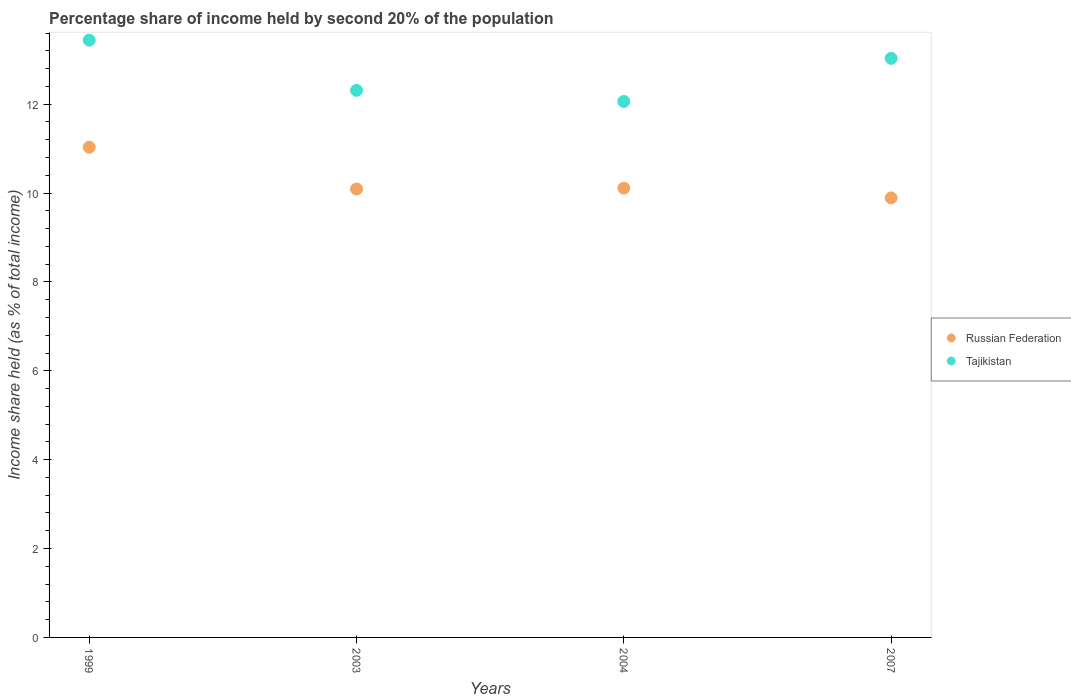How many different coloured dotlines are there?
Provide a succinct answer. 2. What is the share of income held by second 20% of the population in Russian Federation in 2004?
Provide a short and direct response. 10.11. Across all years, what is the maximum share of income held by second 20% of the population in Russian Federation?
Your answer should be very brief. 11.03. Across all years, what is the minimum share of income held by second 20% of the population in Russian Federation?
Offer a very short reply. 9.89. In which year was the share of income held by second 20% of the population in Tajikistan maximum?
Offer a very short reply. 1999. What is the total share of income held by second 20% of the population in Russian Federation in the graph?
Your answer should be compact. 41.12. What is the difference between the share of income held by second 20% of the population in Tajikistan in 1999 and that in 2007?
Ensure brevity in your answer.  0.41. What is the difference between the share of income held by second 20% of the population in Russian Federation in 2004 and the share of income held by second 20% of the population in Tajikistan in 1999?
Your answer should be very brief. -3.33. What is the average share of income held by second 20% of the population in Tajikistan per year?
Offer a very short reply. 12.71. In the year 1999, what is the difference between the share of income held by second 20% of the population in Tajikistan and share of income held by second 20% of the population in Russian Federation?
Your response must be concise. 2.41. What is the ratio of the share of income held by second 20% of the population in Tajikistan in 1999 to that in 2007?
Your answer should be compact. 1.03. Is the share of income held by second 20% of the population in Tajikistan in 1999 less than that in 2003?
Provide a succinct answer. No. What is the difference between the highest and the second highest share of income held by second 20% of the population in Tajikistan?
Your response must be concise. 0.41. What is the difference between the highest and the lowest share of income held by second 20% of the population in Tajikistan?
Your answer should be very brief. 1.38. In how many years, is the share of income held by second 20% of the population in Russian Federation greater than the average share of income held by second 20% of the population in Russian Federation taken over all years?
Your response must be concise. 1. Does the share of income held by second 20% of the population in Russian Federation monotonically increase over the years?
Make the answer very short. No. Is the share of income held by second 20% of the population in Tajikistan strictly less than the share of income held by second 20% of the population in Russian Federation over the years?
Ensure brevity in your answer.  No. Are the values on the major ticks of Y-axis written in scientific E-notation?
Your response must be concise. No. Does the graph contain any zero values?
Provide a succinct answer. No. Does the graph contain grids?
Offer a very short reply. No. Where does the legend appear in the graph?
Make the answer very short. Center right. How are the legend labels stacked?
Your answer should be very brief. Vertical. What is the title of the graph?
Offer a very short reply. Percentage share of income held by second 20% of the population. What is the label or title of the X-axis?
Your response must be concise. Years. What is the label or title of the Y-axis?
Provide a succinct answer. Income share held (as % of total income). What is the Income share held (as % of total income) of Russian Federation in 1999?
Your answer should be very brief. 11.03. What is the Income share held (as % of total income) in Tajikistan in 1999?
Offer a terse response. 13.44. What is the Income share held (as % of total income) in Russian Federation in 2003?
Provide a short and direct response. 10.09. What is the Income share held (as % of total income) in Tajikistan in 2003?
Provide a succinct answer. 12.31. What is the Income share held (as % of total income) of Russian Federation in 2004?
Make the answer very short. 10.11. What is the Income share held (as % of total income) in Tajikistan in 2004?
Your answer should be very brief. 12.06. What is the Income share held (as % of total income) of Russian Federation in 2007?
Your answer should be very brief. 9.89. What is the Income share held (as % of total income) of Tajikistan in 2007?
Offer a terse response. 13.03. Across all years, what is the maximum Income share held (as % of total income) in Russian Federation?
Give a very brief answer. 11.03. Across all years, what is the maximum Income share held (as % of total income) of Tajikistan?
Give a very brief answer. 13.44. Across all years, what is the minimum Income share held (as % of total income) in Russian Federation?
Provide a short and direct response. 9.89. Across all years, what is the minimum Income share held (as % of total income) of Tajikistan?
Your response must be concise. 12.06. What is the total Income share held (as % of total income) in Russian Federation in the graph?
Your response must be concise. 41.12. What is the total Income share held (as % of total income) of Tajikistan in the graph?
Your response must be concise. 50.84. What is the difference between the Income share held (as % of total income) of Tajikistan in 1999 and that in 2003?
Your response must be concise. 1.13. What is the difference between the Income share held (as % of total income) of Russian Federation in 1999 and that in 2004?
Offer a very short reply. 0.92. What is the difference between the Income share held (as % of total income) in Tajikistan in 1999 and that in 2004?
Keep it short and to the point. 1.38. What is the difference between the Income share held (as % of total income) of Russian Federation in 1999 and that in 2007?
Ensure brevity in your answer.  1.14. What is the difference between the Income share held (as % of total income) of Tajikistan in 1999 and that in 2007?
Provide a short and direct response. 0.41. What is the difference between the Income share held (as % of total income) in Russian Federation in 2003 and that in 2004?
Offer a very short reply. -0.02. What is the difference between the Income share held (as % of total income) of Tajikistan in 2003 and that in 2007?
Make the answer very short. -0.72. What is the difference between the Income share held (as % of total income) in Russian Federation in 2004 and that in 2007?
Give a very brief answer. 0.22. What is the difference between the Income share held (as % of total income) of Tajikistan in 2004 and that in 2007?
Offer a very short reply. -0.97. What is the difference between the Income share held (as % of total income) in Russian Federation in 1999 and the Income share held (as % of total income) in Tajikistan in 2003?
Your response must be concise. -1.28. What is the difference between the Income share held (as % of total income) of Russian Federation in 1999 and the Income share held (as % of total income) of Tajikistan in 2004?
Ensure brevity in your answer.  -1.03. What is the difference between the Income share held (as % of total income) of Russian Federation in 2003 and the Income share held (as % of total income) of Tajikistan in 2004?
Offer a very short reply. -1.97. What is the difference between the Income share held (as % of total income) in Russian Federation in 2003 and the Income share held (as % of total income) in Tajikistan in 2007?
Offer a very short reply. -2.94. What is the difference between the Income share held (as % of total income) in Russian Federation in 2004 and the Income share held (as % of total income) in Tajikistan in 2007?
Your answer should be very brief. -2.92. What is the average Income share held (as % of total income) of Russian Federation per year?
Make the answer very short. 10.28. What is the average Income share held (as % of total income) in Tajikistan per year?
Your answer should be very brief. 12.71. In the year 1999, what is the difference between the Income share held (as % of total income) of Russian Federation and Income share held (as % of total income) of Tajikistan?
Offer a very short reply. -2.41. In the year 2003, what is the difference between the Income share held (as % of total income) of Russian Federation and Income share held (as % of total income) of Tajikistan?
Ensure brevity in your answer.  -2.22. In the year 2004, what is the difference between the Income share held (as % of total income) in Russian Federation and Income share held (as % of total income) in Tajikistan?
Offer a very short reply. -1.95. In the year 2007, what is the difference between the Income share held (as % of total income) of Russian Federation and Income share held (as % of total income) of Tajikistan?
Make the answer very short. -3.14. What is the ratio of the Income share held (as % of total income) of Russian Federation in 1999 to that in 2003?
Keep it short and to the point. 1.09. What is the ratio of the Income share held (as % of total income) in Tajikistan in 1999 to that in 2003?
Your response must be concise. 1.09. What is the ratio of the Income share held (as % of total income) of Russian Federation in 1999 to that in 2004?
Your answer should be very brief. 1.09. What is the ratio of the Income share held (as % of total income) in Tajikistan in 1999 to that in 2004?
Provide a short and direct response. 1.11. What is the ratio of the Income share held (as % of total income) of Russian Federation in 1999 to that in 2007?
Provide a succinct answer. 1.12. What is the ratio of the Income share held (as % of total income) of Tajikistan in 1999 to that in 2007?
Your answer should be very brief. 1.03. What is the ratio of the Income share held (as % of total income) in Russian Federation in 2003 to that in 2004?
Keep it short and to the point. 1. What is the ratio of the Income share held (as % of total income) of Tajikistan in 2003 to that in 2004?
Offer a very short reply. 1.02. What is the ratio of the Income share held (as % of total income) in Russian Federation in 2003 to that in 2007?
Your answer should be compact. 1.02. What is the ratio of the Income share held (as % of total income) in Tajikistan in 2003 to that in 2007?
Ensure brevity in your answer.  0.94. What is the ratio of the Income share held (as % of total income) in Russian Federation in 2004 to that in 2007?
Make the answer very short. 1.02. What is the ratio of the Income share held (as % of total income) in Tajikistan in 2004 to that in 2007?
Your answer should be compact. 0.93. What is the difference between the highest and the second highest Income share held (as % of total income) of Tajikistan?
Your response must be concise. 0.41. What is the difference between the highest and the lowest Income share held (as % of total income) of Russian Federation?
Your response must be concise. 1.14. What is the difference between the highest and the lowest Income share held (as % of total income) in Tajikistan?
Provide a short and direct response. 1.38. 